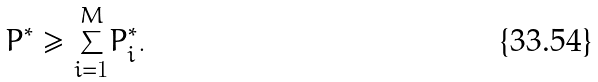<formula> <loc_0><loc_0><loc_500><loc_500>P ^ { * } \geq \underset { i = 1 } { \overset { M } { \sum } } P _ { i } ^ { * } .</formula> 